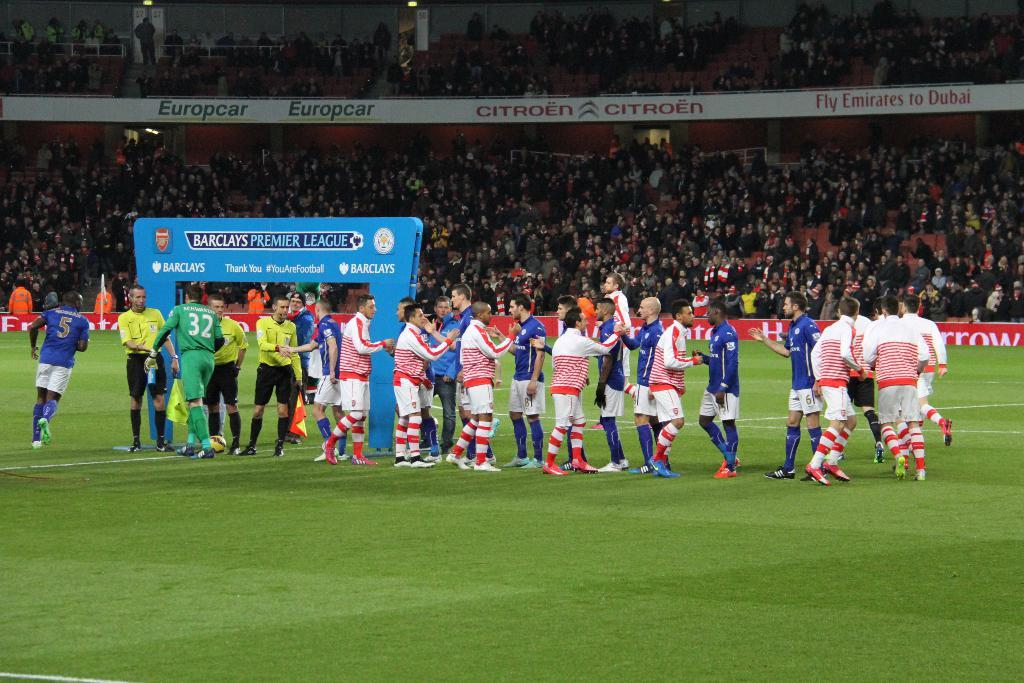<image>
Provide a brief description of the given image. Players on soccer teams stand near a banner that reads "Barclays Premier League". 